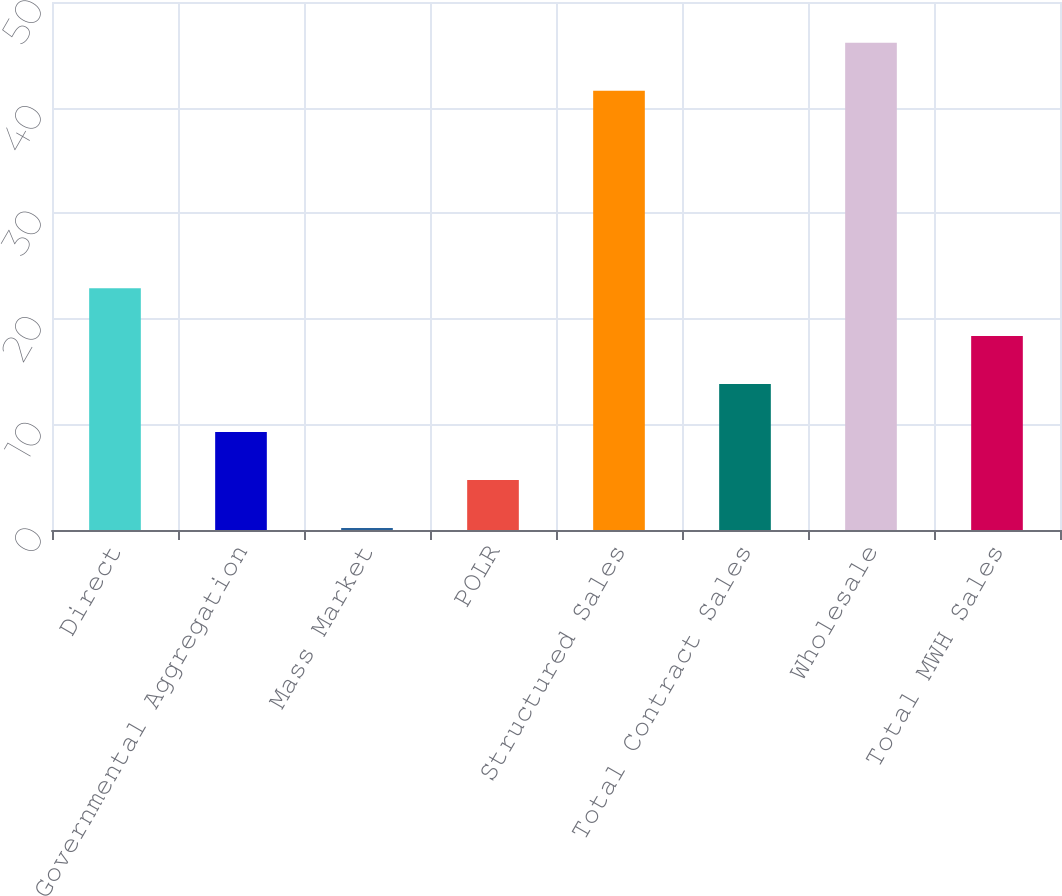Convert chart. <chart><loc_0><loc_0><loc_500><loc_500><bar_chart><fcel>Direct<fcel>Governmental Aggregation<fcel>Mass Market<fcel>POLR<fcel>Structured Sales<fcel>Total Contract Sales<fcel>Wholesale<fcel>Total MWH Sales<nl><fcel>22.9<fcel>9.28<fcel>0.2<fcel>4.74<fcel>41.6<fcel>13.82<fcel>46.14<fcel>18.36<nl></chart> 